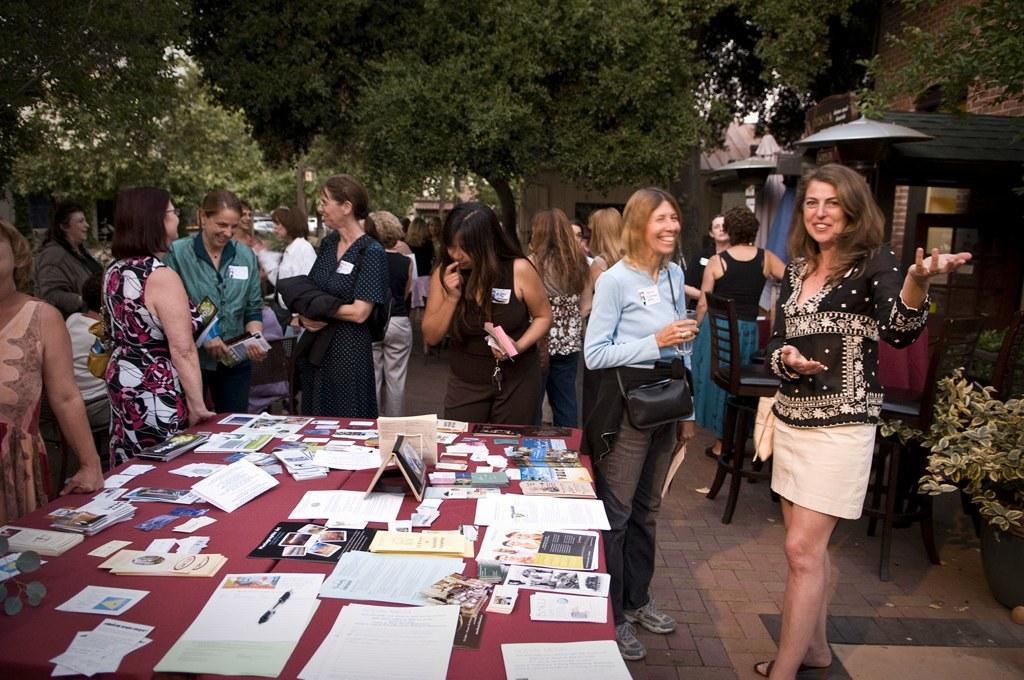Could you give a brief overview of what you see in this image? This picture shows few people standing and we see a woman holding a glass in her hand and a bag on the shoulder and papers in her hand and we see few papers and books on the table and we see trees and few buildings. 